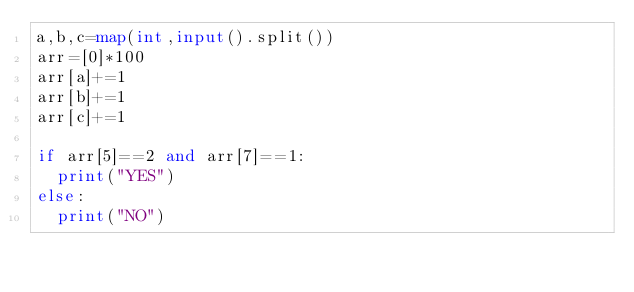<code> <loc_0><loc_0><loc_500><loc_500><_Python_>a,b,c=map(int,input().split())
arr=[0]*100
arr[a]+=1
arr[b]+=1
arr[c]+=1

if arr[5]==2 and arr[7]==1:
  print("YES")
else:
  print("NO")
</code> 